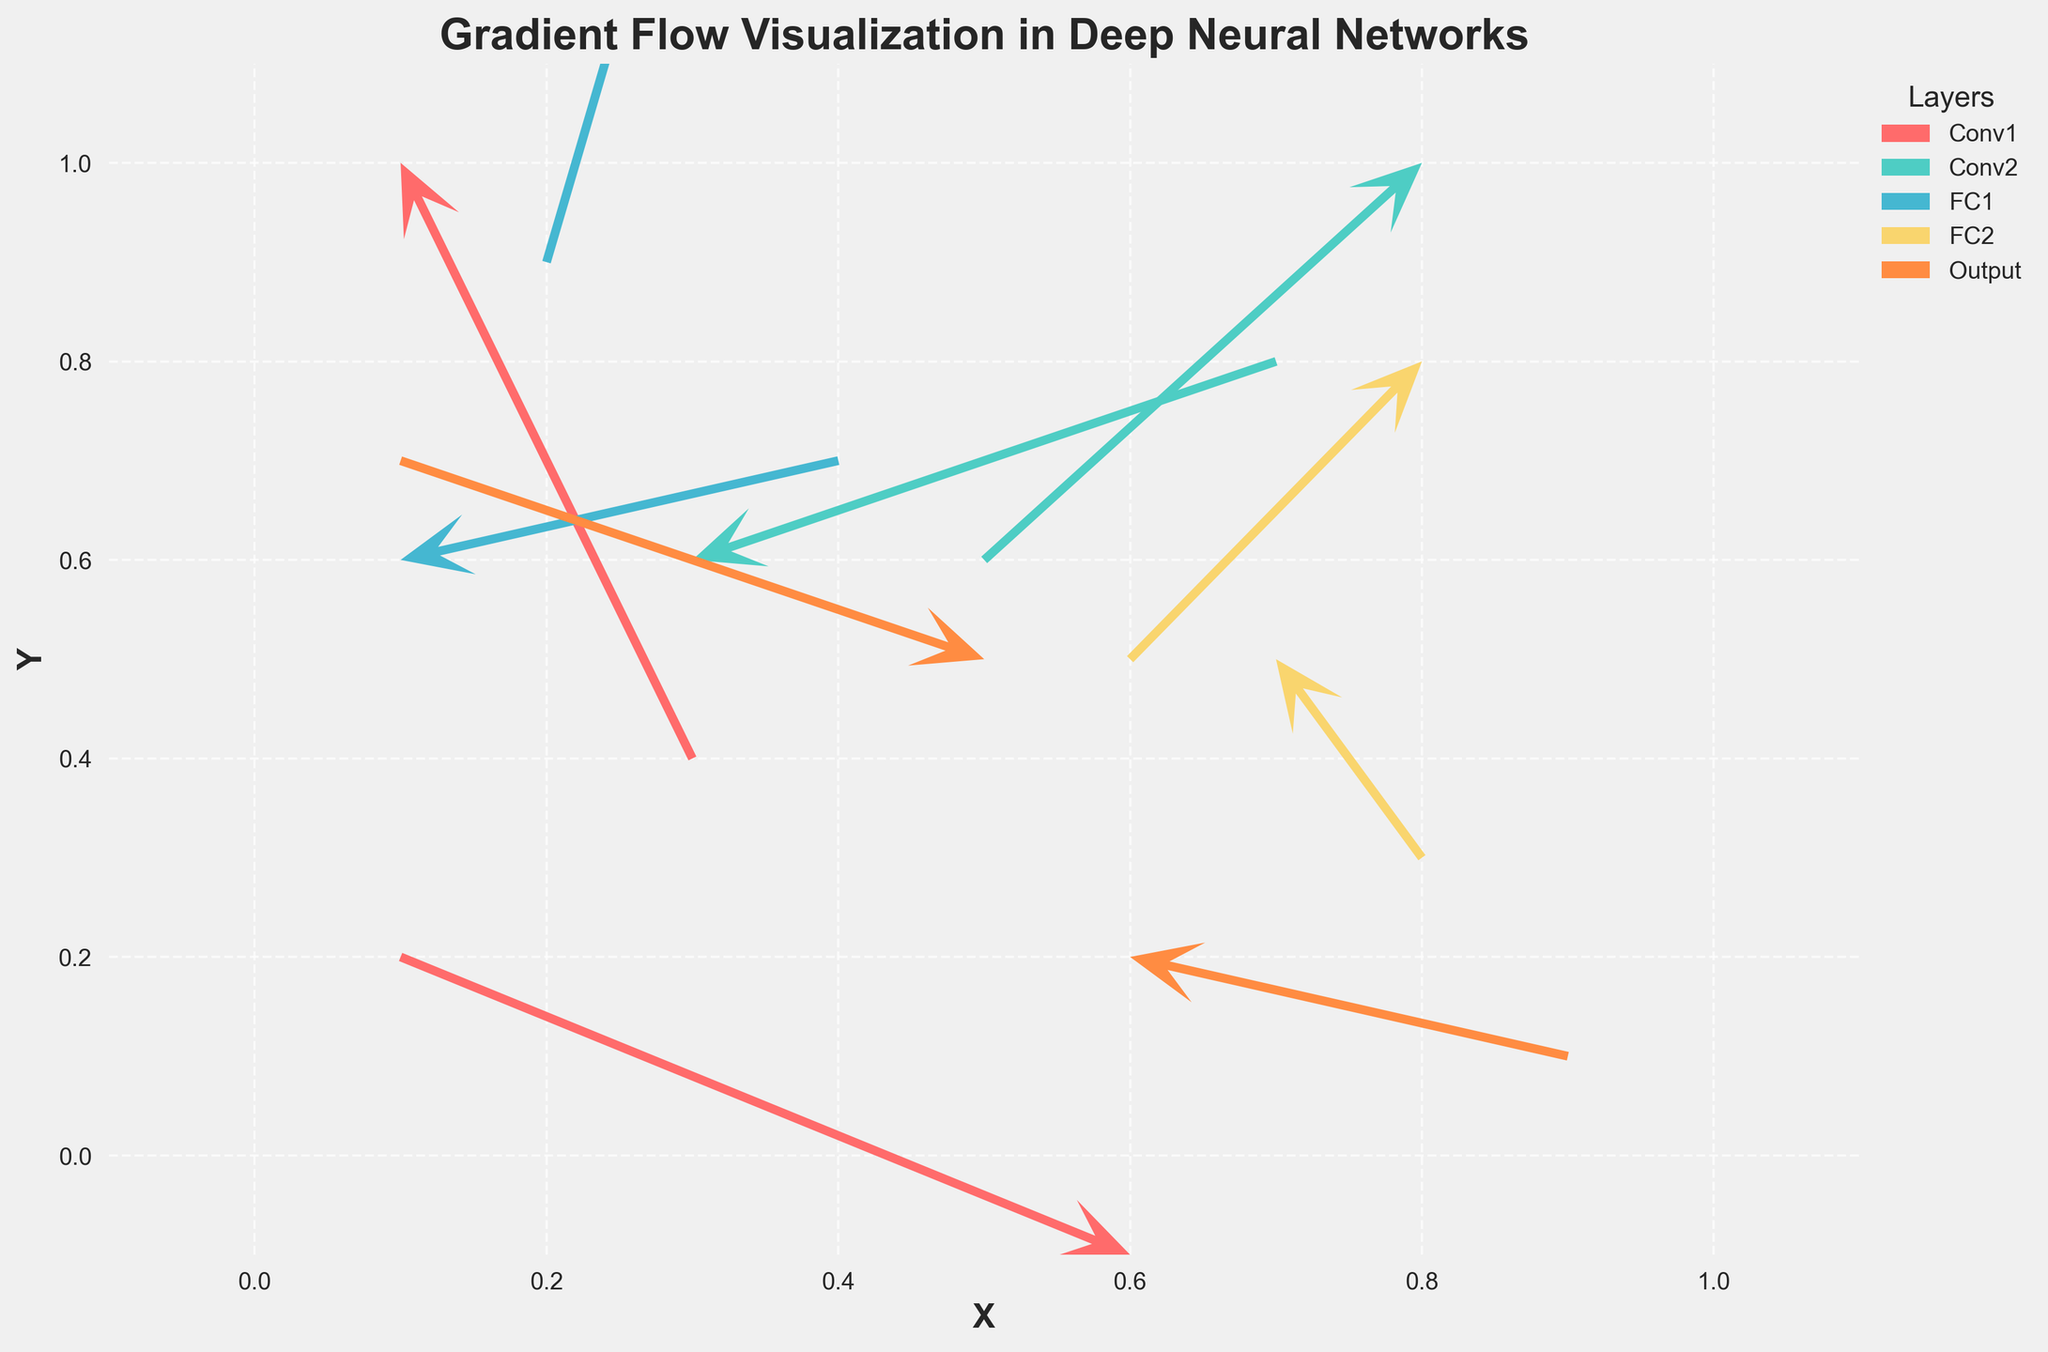What's the title of the plot? The title is typically found at the top of the plot, displayed in larger or bolder fonts to make it stand out. In this case, the title is "Gradient Flow Visualization in Deep Neural Networks".
Answer: Gradient Flow Visualization in Deep Neural Networks How many different layers are represented in the plot? The legend indicates the layers by assigning different colors to each. There are five colors corresponding to five different layer names in the legend.
Answer: Five Which axis represents the 'X' coordinate? The label "X" is found at the bottom of the horizontal axis, indicating it represents the 'X' coordinate.
Answer: Horizontal axis What color represents the 'Conv1' layer in the plot? The legend beside the plot matches the layer names with their respective colors. 'Conv1' is represented by a salmon pink color.
Answer: Salmon pink Which layer has a quiver pointing in the negative X and negative Y direction? From the given data and observing the plot, we can see 'Conv2' has a quiver pointing in the negative X (-0.04) and Y (-0.02) directions at coordinates (0.7, 0.8).
Answer: Conv2 How many vectors (quivers) are associated with 'FC2' layer? By looking at the data presented and verifying the plot, 'FC2' has vectors at (0.6, 0.5) and (0.8, 0.3), making for a total of two vectors.
Answer: Two What are the coordinate positions for the 'Output' layer vectors? Referring directly to the data, the 'Output' layer vectors are located at (0.1, 0.7) and (0.9, 0.1). This can be verified visually in the plot.
Answer: (0.1, 0.7) and (0.9, 0.1) Which vector has the longest magnitude in the 'FC1' layer? For 'FC1', vectors are at (0.2, 0.9) and (0.4, 0.7). Magnitudes are calculated using the Euclidean norm sqrt(u^2 + v^2). For (0.2, 0.9), it is sqrt(0.01^2 + 0.05^2) ≈ 0.051, and for (0.4, 0.7) it is sqrt(-0.03^2 + -0.01^2) ≈ 0.032. The vector at (0.2, 0.9) has the longer magnitude.
Answer: (0.2, 0.9) Which layer has the most vectors pointing primarily in the positive Y direction? Examining the vectors in the plot, we see that the 'FC1' layer has both vectors primarily pointed in the positive Y direction (0.01, 0.05) and (-0.03, -0.01). Thus 'FC1' layer wins out in this context.
Answer: FC1 